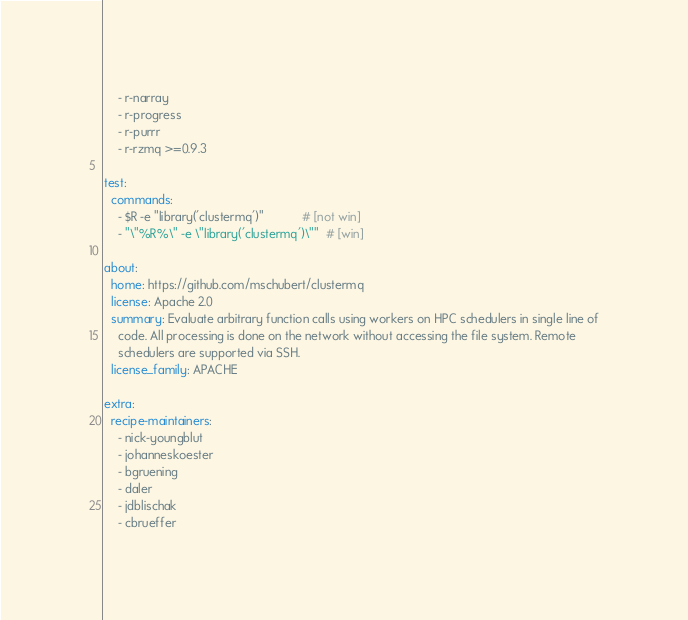<code> <loc_0><loc_0><loc_500><loc_500><_YAML_>    - r-narray
    - r-progress
    - r-purrr
    - r-rzmq >=0.9.3

test:
  commands:
    - $R -e "library('clustermq')"           # [not win]
    - "\"%R%\" -e \"library('clustermq')\""  # [win]

about:
  home: https://github.com/mschubert/clustermq
  license: Apache 2.0
  summary: Evaluate arbitrary function calls using workers on HPC schedulers in single line of
    code. All processing is done on the network without accessing the file system. Remote
    schedulers are supported via SSH.
  license_family: APACHE

extra:
  recipe-maintainers:
    - nick-youngblut
    - johanneskoester
    - bgruening
    - daler
    - jdblischak
    - cbrueffer
</code> 